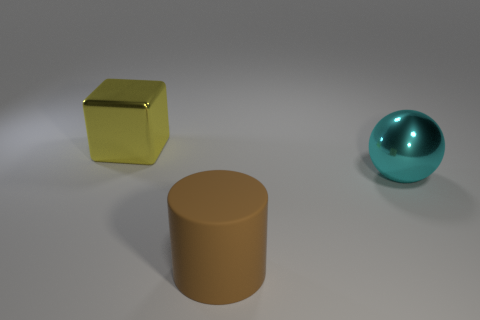Add 3 green cylinders. How many objects exist? 6 Subtract all spheres. How many objects are left? 2 Subtract all big yellow things. Subtract all large green rubber cylinders. How many objects are left? 2 Add 3 cyan metallic balls. How many cyan metallic balls are left? 4 Add 1 cylinders. How many cylinders exist? 2 Subtract 0 brown blocks. How many objects are left? 3 